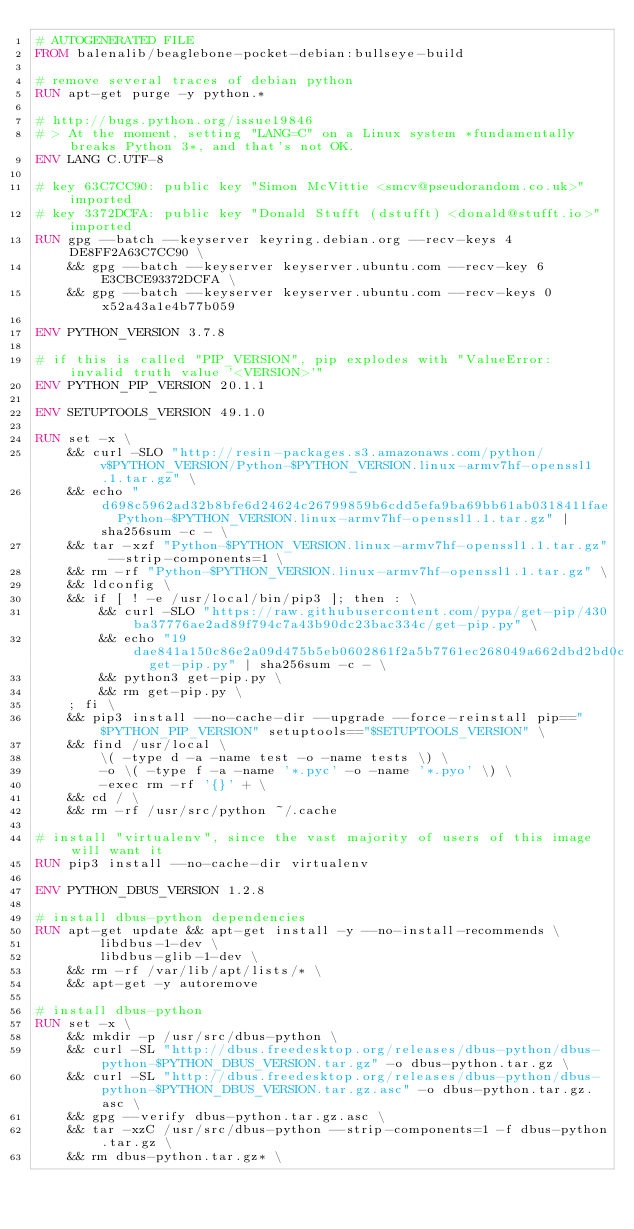Convert code to text. <code><loc_0><loc_0><loc_500><loc_500><_Dockerfile_># AUTOGENERATED FILE
FROM balenalib/beaglebone-pocket-debian:bullseye-build

# remove several traces of debian python
RUN apt-get purge -y python.*

# http://bugs.python.org/issue19846
# > At the moment, setting "LANG=C" on a Linux system *fundamentally breaks Python 3*, and that's not OK.
ENV LANG C.UTF-8

# key 63C7CC90: public key "Simon McVittie <smcv@pseudorandom.co.uk>" imported
# key 3372DCFA: public key "Donald Stufft (dstufft) <donald@stufft.io>" imported
RUN gpg --batch --keyserver keyring.debian.org --recv-keys 4DE8FF2A63C7CC90 \
	&& gpg --batch --keyserver keyserver.ubuntu.com --recv-key 6E3CBCE93372DCFA \
	&& gpg --batch --keyserver keyserver.ubuntu.com --recv-keys 0x52a43a1e4b77b059

ENV PYTHON_VERSION 3.7.8

# if this is called "PIP_VERSION", pip explodes with "ValueError: invalid truth value '<VERSION>'"
ENV PYTHON_PIP_VERSION 20.1.1

ENV SETUPTOOLS_VERSION 49.1.0

RUN set -x \
	&& curl -SLO "http://resin-packages.s3.amazonaws.com/python/v$PYTHON_VERSION/Python-$PYTHON_VERSION.linux-armv7hf-openssl1.1.tar.gz" \
	&& echo "d698c5962ad32b8bfe6d24624c26799859b6cdd5efa9ba69bb61ab0318411fae  Python-$PYTHON_VERSION.linux-armv7hf-openssl1.1.tar.gz" | sha256sum -c - \
	&& tar -xzf "Python-$PYTHON_VERSION.linux-armv7hf-openssl1.1.tar.gz" --strip-components=1 \
	&& rm -rf "Python-$PYTHON_VERSION.linux-armv7hf-openssl1.1.tar.gz" \
	&& ldconfig \
	&& if [ ! -e /usr/local/bin/pip3 ]; then : \
		&& curl -SLO "https://raw.githubusercontent.com/pypa/get-pip/430ba37776ae2ad89f794c7a43b90dc23bac334c/get-pip.py" \
		&& echo "19dae841a150c86e2a09d475b5eb0602861f2a5b7761ec268049a662dbd2bd0c  get-pip.py" | sha256sum -c - \
		&& python3 get-pip.py \
		&& rm get-pip.py \
	; fi \
	&& pip3 install --no-cache-dir --upgrade --force-reinstall pip=="$PYTHON_PIP_VERSION" setuptools=="$SETUPTOOLS_VERSION" \
	&& find /usr/local \
		\( -type d -a -name test -o -name tests \) \
		-o \( -type f -a -name '*.pyc' -o -name '*.pyo' \) \
		-exec rm -rf '{}' + \
	&& cd / \
	&& rm -rf /usr/src/python ~/.cache

# install "virtualenv", since the vast majority of users of this image will want it
RUN pip3 install --no-cache-dir virtualenv

ENV PYTHON_DBUS_VERSION 1.2.8

# install dbus-python dependencies 
RUN apt-get update && apt-get install -y --no-install-recommends \
		libdbus-1-dev \
		libdbus-glib-1-dev \
	&& rm -rf /var/lib/apt/lists/* \
	&& apt-get -y autoremove

# install dbus-python
RUN set -x \
	&& mkdir -p /usr/src/dbus-python \
	&& curl -SL "http://dbus.freedesktop.org/releases/dbus-python/dbus-python-$PYTHON_DBUS_VERSION.tar.gz" -o dbus-python.tar.gz \
	&& curl -SL "http://dbus.freedesktop.org/releases/dbus-python/dbus-python-$PYTHON_DBUS_VERSION.tar.gz.asc" -o dbus-python.tar.gz.asc \
	&& gpg --verify dbus-python.tar.gz.asc \
	&& tar -xzC /usr/src/dbus-python --strip-components=1 -f dbus-python.tar.gz \
	&& rm dbus-python.tar.gz* \</code> 